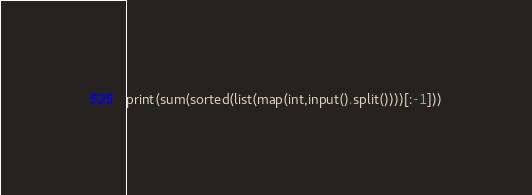Convert code to text. <code><loc_0><loc_0><loc_500><loc_500><_Python_>print(sum(sorted(list(map(int,input().split())))[:-1]))</code> 